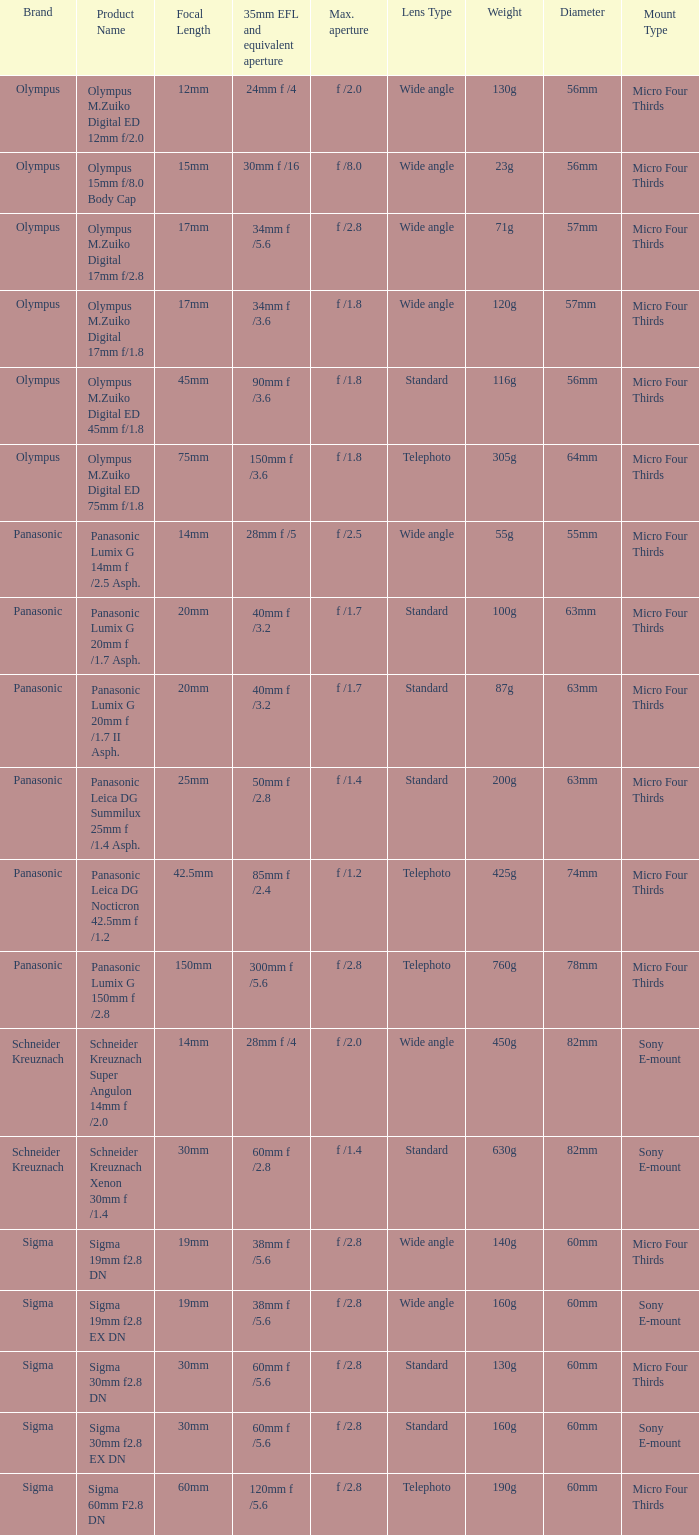What is the brand of the Sigma 30mm f2.8 DN, which has a maximum aperture of f /2.8 and a focal length of 30mm? Sigma. 